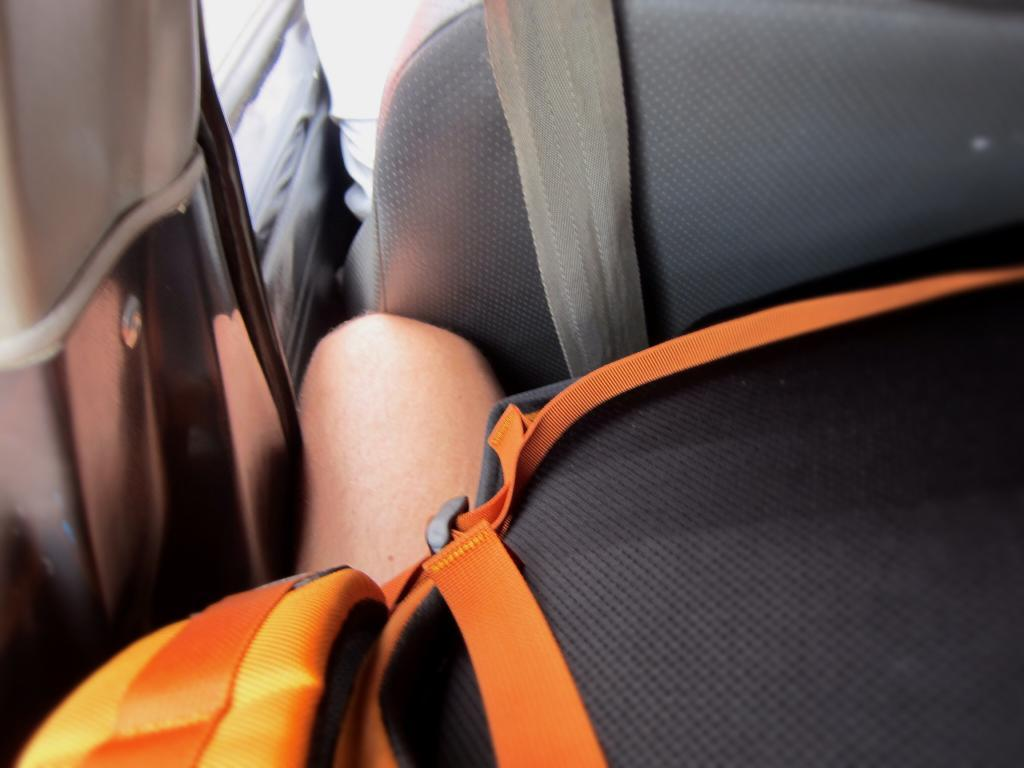What part of a person can be seen in the image? There is a person's leg visible in the image. Where is the person's leg located? The person's leg is inside a car. What type of bag is near the leg? There is a black and orange color bag near the leg. What is behind the leg in the image? There is a seat behind the leg. What safety feature is present in the image? A seat belt is present in the image. What type of stem can be seen growing from the person's leg in the image? There is no stem growing from the person's leg in the image. Can you tell me how many moms are present in the image? There is no mention of a mom or any people other than the person whose leg is visible in the image. 